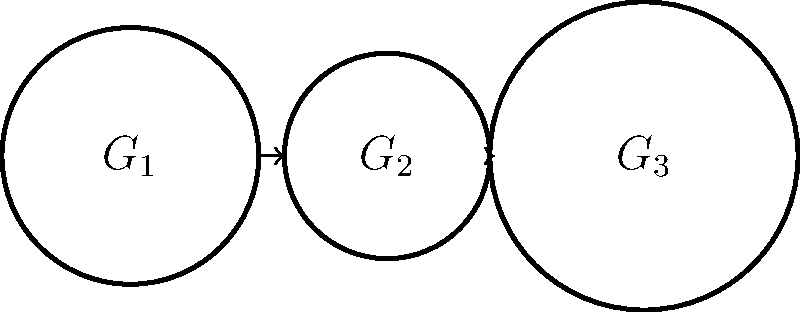In a transmission system, three gears $G_1$, $G_2$, and $G_3$ are connected as shown in the diagram. The number of teeth on each gear forms a group under multiplication modulo 360. If $G_1$ has 36 teeth, $G_2$ has 24 teeth, and $G_3$ has 48 teeth, what is the order of the group generated by the gear ratios? Assume that one full rotation of $G_1$ is considered as the identity element. To solve this problem, we'll follow these steps:

1) First, let's calculate the gear ratios:
   $R_1 = \frac{G_2}{G_1} = \frac{24}{36} = \frac{2}{3}$
   $R_2 = \frac{G_3}{G_2} = \frac{48}{24} = 2$

2) The overall gear ratio from $G_1$ to $G_3$ is:
   $R_{total} = R_1 \times R_2 = \frac{2}{3} \times 2 = \frac{4}{3}$

3) This means that for every full rotation of $G_1$, $G_3$ rotates $\frac{4}{3}$ times.

4) To find when both gears return to their starting positions simultaneously (which represents the identity element in our group), we need to find the least common multiple (LCM) of the denominators of these fractions when expressed as rotations:
   $G_1: 1 = \frac{3}{3}$
   $G_3: \frac{4}{3}$

5) The LCM of 3 and 3 is 3. This means after 3 full rotations of $G_1$, both gears will return to their starting positions.

6) During these 3 rotations of $G_1$, $G_3$ will rotate $3 \times \frac{4}{3} = 4$ times.

7) Therefore, the group generated by these gear ratios has an order of 3, as it takes 3 applications of the gear ratio to return to the identity element.
Answer: 3 